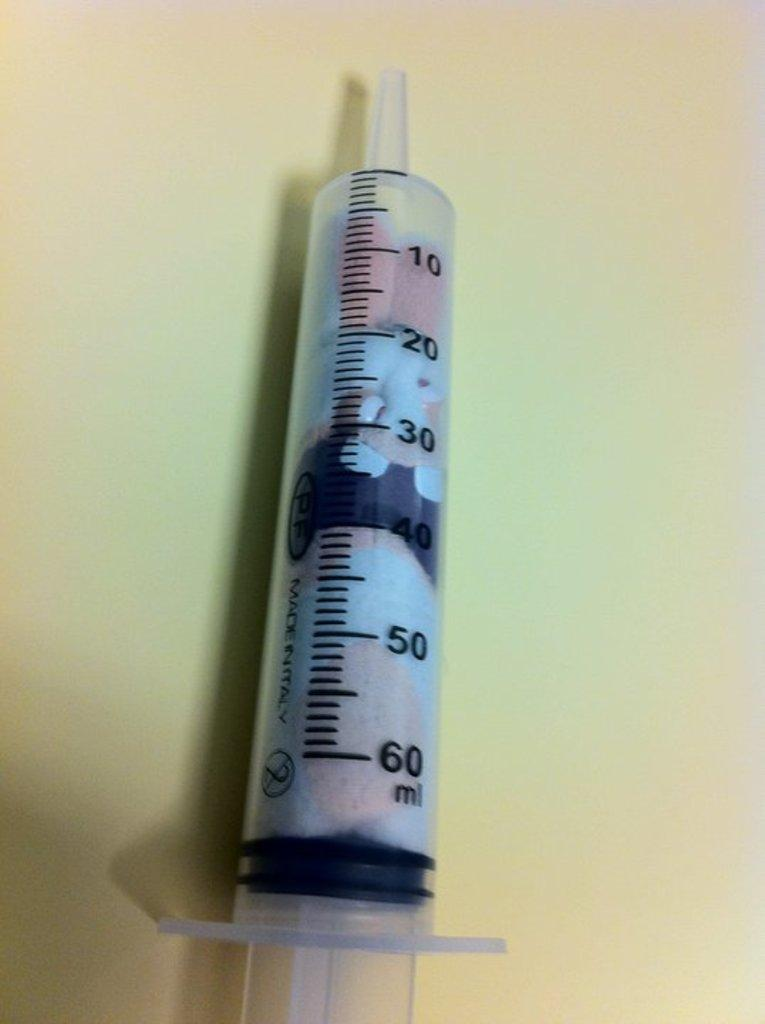What is the main subject in the center of the image? There is an injection in the center of the image. What can be seen in the background of the image? There is a wall visible in the background of the image. What type of destruction can be seen happening to the sand in the image? There is no sand or destruction present in the image; it features an injection and a wall in the background. What type of chess pieces are visible on the wall in the image? There are no chess pieces visible on the wall in the image. 